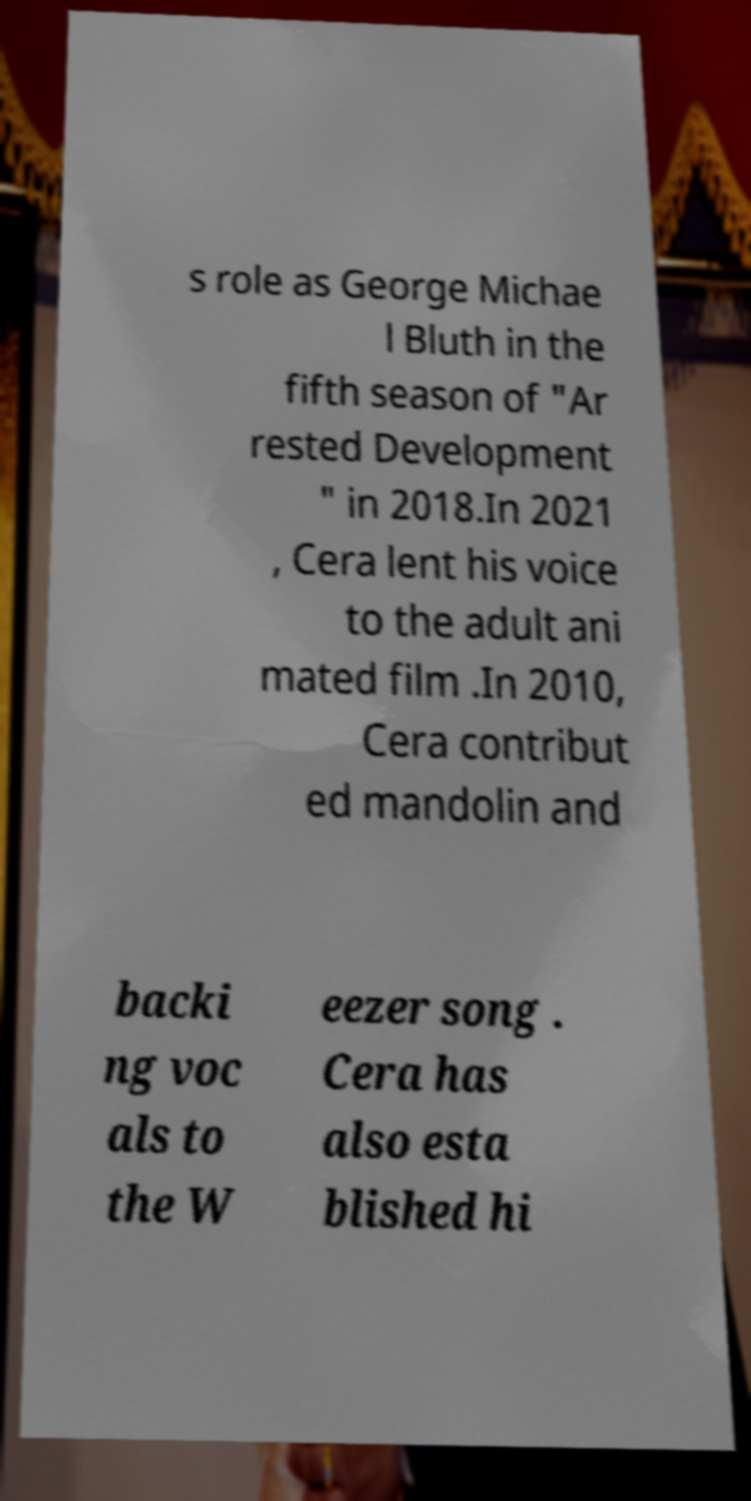Please identify and transcribe the text found in this image. s role as George Michae l Bluth in the fifth season of "Ar rested Development " in 2018.In 2021 , Cera lent his voice to the adult ani mated film .In 2010, Cera contribut ed mandolin and backi ng voc als to the W eezer song . Cera has also esta blished hi 